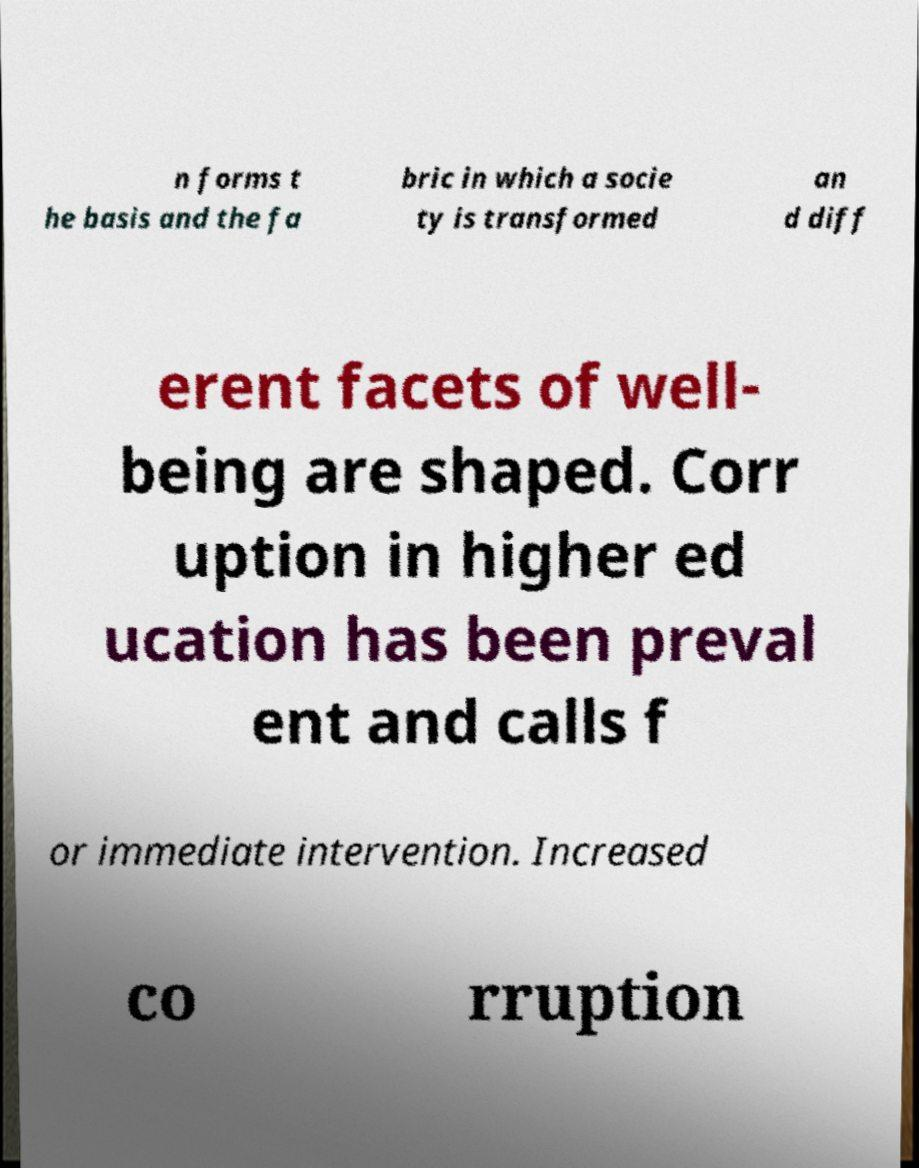I need the written content from this picture converted into text. Can you do that? n forms t he basis and the fa bric in which a socie ty is transformed an d diff erent facets of well- being are shaped. Corr uption in higher ed ucation has been preval ent and calls f or immediate intervention. Increased co rruption 